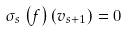Convert formula to latex. <formula><loc_0><loc_0><loc_500><loc_500>\sigma _ { s } \left ( f \right ) \left ( v _ { s + 1 } \right ) = 0</formula> 